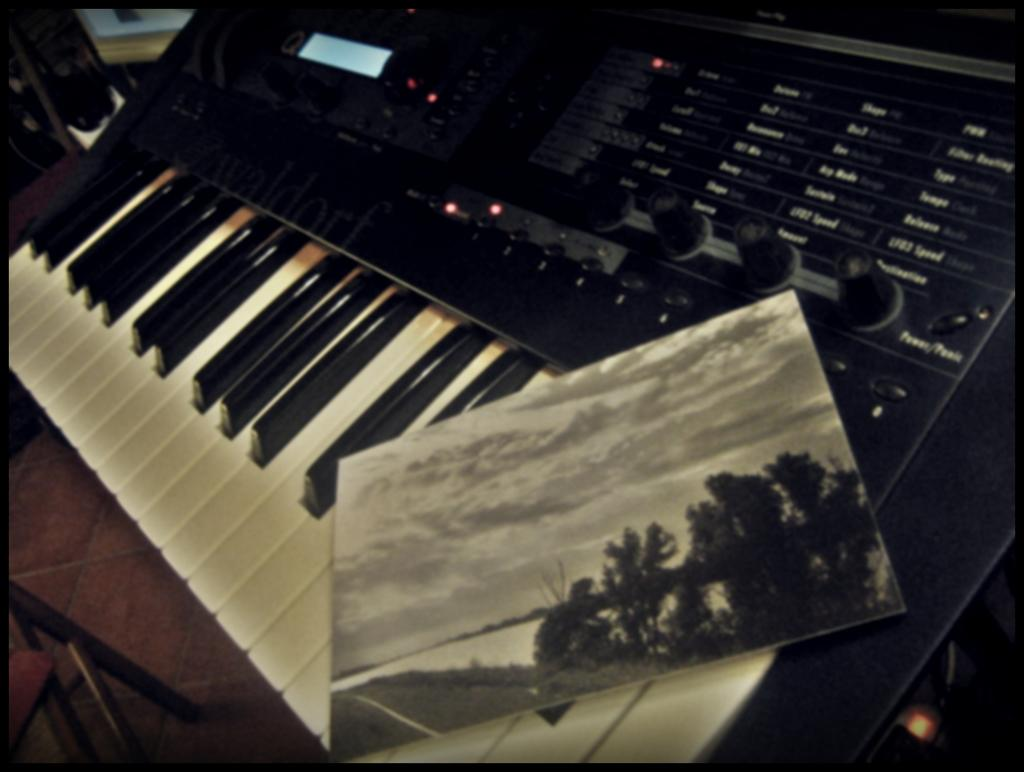What type of instrument is in the image? There is a musical keyboard in the image. Is there anything placed on the musical keyboard? Yes, there is a photo frame on the musical keyboard. What piece of furniture is in the image? There is a table in the image. Where is the musical keyboard located? The musical keyboard is placed on the table. What type of bear can be seen eating rice in the image? There is no bear or rice present in the image; it features a musical keyboard and a photo frame on a table. 